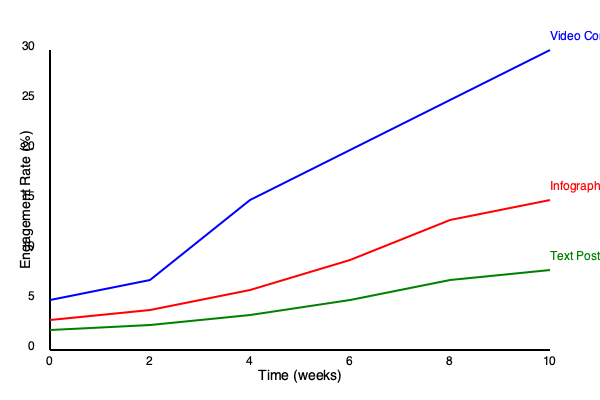Based on the line graph showing engagement rates for different social media content types over a 10-week period, which strategy would you recommend for a civil rights campaign aiming to maximize audience engagement in the long term, and why? To answer this question, we need to analyze the trends for each content type:

1. Video Content (Blue line):
   - Starts at around 5% engagement
   - Shows the steepest upward trend
   - Reaches the highest engagement rate of about 28% by week 10

2. Infographics (Red line):
   - Starts at about 3% engagement
   - Shows a moderate upward trend
   - Reaches about 15% engagement by week 10

3. Text Posts (Green line):
   - Starts at about 2% engagement
   - Shows the slowest growth
   - Reaches about 8% engagement by week 10

For a civil rights campaign aiming to maximize audience engagement in the long term:

1. Video content is the most effective strategy:
   - It shows the highest growth rate over time
   - It achieves the highest overall engagement by week 10
   - Visual content is often more engaging and can convey complex ideas effectively

2. Infographics are the second-best option:
   - They show moderate growth and engagement
   - They can be useful for presenting data and statistics related to civil rights issues

3. Text posts are the least effective:
   - They show the slowest growth and lowest overall engagement
   - However, they may still be useful for quick updates or detailed explanations

Considering the long-term goal, video content would be the most recommended strategy. It not only provides the highest engagement rate but also shows the potential for continued growth beyond the 10-week period. Videos can effectively communicate emotional stories, explain complex civil rights issues, and showcase the human impact of campaigns, making them particularly suitable for a civil rights-focused campaign.
Answer: Video content, due to highest engagement rate and steepest growth trend. 